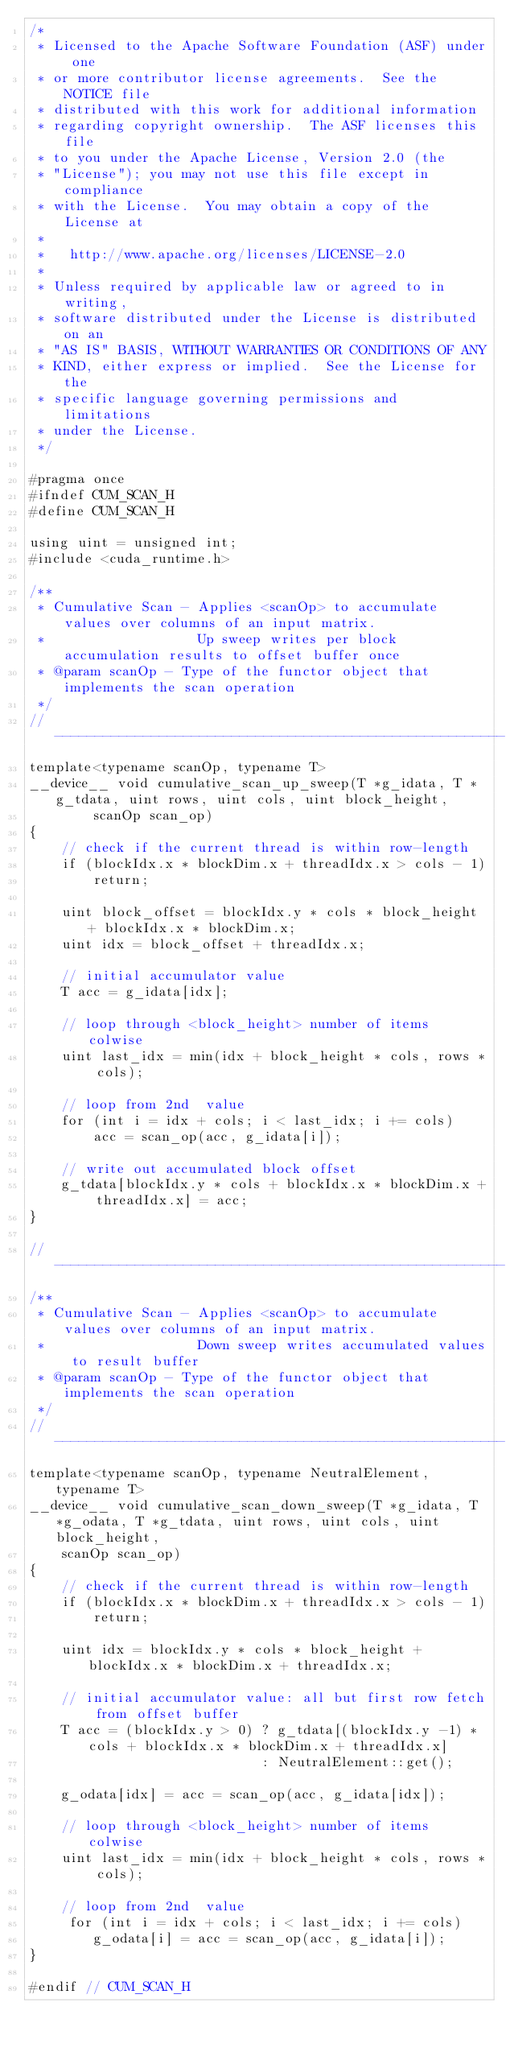<code> <loc_0><loc_0><loc_500><loc_500><_Cuda_>/*
 * Licensed to the Apache Software Foundation (ASF) under one
 * or more contributor license agreements.  See the NOTICE file
 * distributed with this work for additional information
 * regarding copyright ownership.  The ASF licenses this file
 * to you under the Apache License, Version 2.0 (the
 * "License"); you may not use this file except in compliance
 * with the License.  You may obtain a copy of the License at
 *
 *   http://www.apache.org/licenses/LICENSE-2.0
 *
 * Unless required by applicable law or agreed to in writing,
 * software distributed under the License is distributed on an
 * "AS IS" BASIS, WITHOUT WARRANTIES OR CONDITIONS OF ANY
 * KIND, either express or implied.  See the License for the
 * specific language governing permissions and limitations
 * under the License.
 */

#pragma once
#ifndef CUM_SCAN_H
#define CUM_SCAN_H

using uint = unsigned int;
#include <cuda_runtime.h>

/**
 * Cumulative Scan - Applies <scanOp> to accumulate values over columns of an input matrix.
 *                   Up sweep writes per block accumulation results to offset buffer once
 * @param scanOp - Type of the functor object that implements the scan operation
 */
// --------------------------------------------------------
template<typename scanOp, typename T>
__device__ void cumulative_scan_up_sweep(T *g_idata, T *g_tdata, uint rows, uint cols, uint block_height, 
		scanOp scan_op)  
{
	// check if the current thread is within row-length
	if (blockIdx.x * blockDim.x + threadIdx.x > cols - 1)
		return;

	uint block_offset = blockIdx.y * cols * block_height + blockIdx.x * blockDim.x;
	uint idx = block_offset + threadIdx.x;

	// initial accumulator value
	T acc = g_idata[idx];

	// loop through <block_height> number of items colwise
	uint last_idx = min(idx + block_height * cols, rows * cols);

	// loop from 2nd  value
	for (int i = idx + cols; i < last_idx; i += cols)
		acc = scan_op(acc, g_idata[i]);

	// write out accumulated block offset
	g_tdata[blockIdx.y * cols + blockIdx.x * blockDim.x + threadIdx.x] = acc;
}

// --------------------------------------------------------
/**
 * Cumulative Scan - Applies <scanOp> to accumulate values over columns of an input matrix.
 *                   Down sweep writes accumulated values to result buffer
 * @param scanOp - Type of the functor object that implements the scan operation
 */
// --------------------------------------------------------
template<typename scanOp, typename NeutralElement, typename T>
__device__ void cumulative_scan_down_sweep(T *g_idata, T *g_odata, T *g_tdata, uint rows, uint cols, uint block_height, 
	scanOp scan_op)
{
	// check if the current thread is within row-length
	if (blockIdx.x * blockDim.x + threadIdx.x > cols - 1)
		return;

	uint idx = blockIdx.y * cols * block_height + blockIdx.x * blockDim.x + threadIdx.x;

	// initial accumulator value: all but first row fetch from offset buffer
	T acc = (blockIdx.y > 0) ? g_tdata[(blockIdx.y -1) * cols + blockIdx.x * blockDim.x + threadIdx.x]
						     : NeutralElement::get();

	g_odata[idx] = acc = scan_op(acc, g_idata[idx]);

	// loop through <block_height> number of items colwise
	uint last_idx = min(idx + block_height * cols, rows * cols);

	// loop from 2nd  value
	 for (int i = idx + cols; i < last_idx; i += cols)
		g_odata[i] = acc = scan_op(acc, g_idata[i]);
}

#endif // CUM_SCAN_H
</code> 